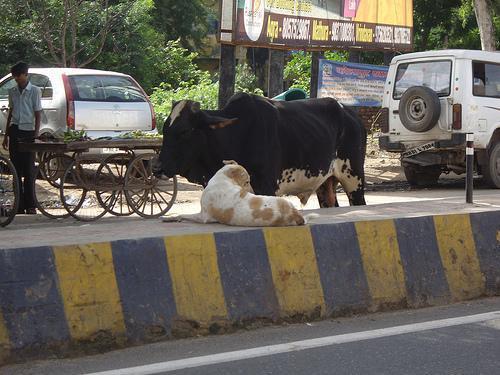How many cows are there?
Give a very brief answer. 1. How many people ar in the picture?
Give a very brief answer. 1. 